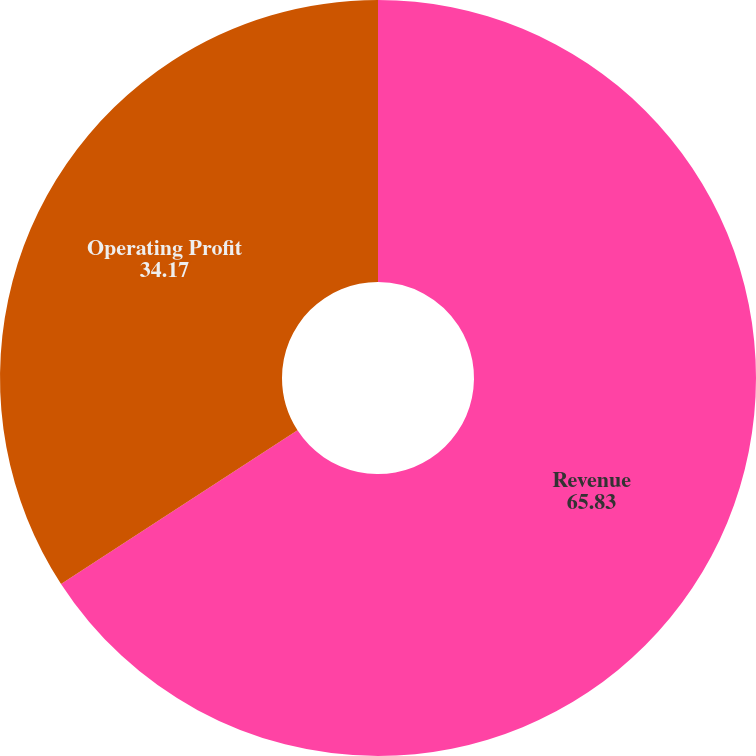Convert chart to OTSL. <chart><loc_0><loc_0><loc_500><loc_500><pie_chart><fcel>Revenue<fcel>Operating Profit<nl><fcel>65.83%<fcel>34.17%<nl></chart> 